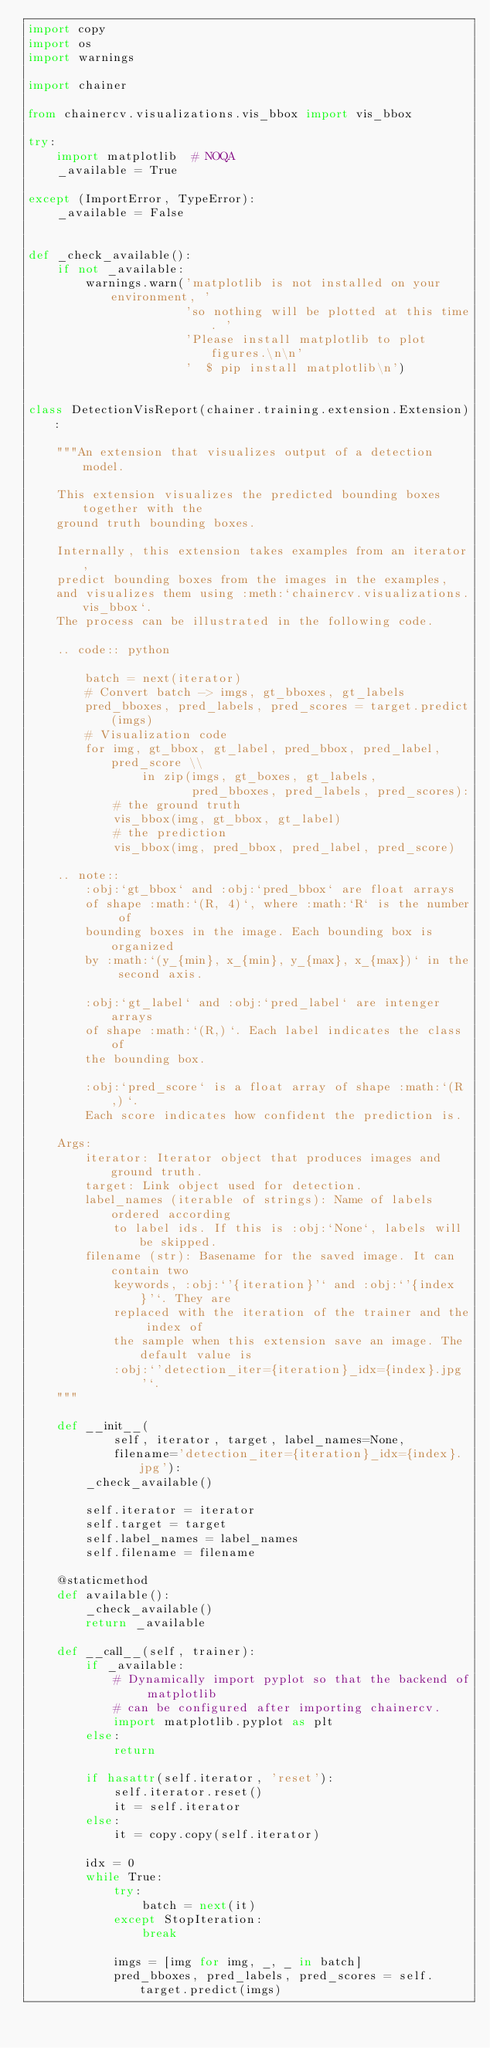<code> <loc_0><loc_0><loc_500><loc_500><_Python_>import copy
import os
import warnings

import chainer

from chainercv.visualizations.vis_bbox import vis_bbox

try:
    import matplotlib  # NOQA
    _available = True

except (ImportError, TypeError):
    _available = False


def _check_available():
    if not _available:
        warnings.warn('matplotlib is not installed on your environment, '
                      'so nothing will be plotted at this time. '
                      'Please install matplotlib to plot figures.\n\n'
                      '  $ pip install matplotlib\n')


class DetectionVisReport(chainer.training.extension.Extension):

    """An extension that visualizes output of a detection model.

    This extension visualizes the predicted bounding boxes together with the
    ground truth bounding boxes.

    Internally, this extension takes examples from an iterator,
    predict bounding boxes from the images in the examples,
    and visualizes them using :meth:`chainercv.visualizations.vis_bbox`.
    The process can be illustrated in the following code.

    .. code:: python

        batch = next(iterator)
        # Convert batch -> imgs, gt_bboxes, gt_labels
        pred_bboxes, pred_labels, pred_scores = target.predict(imgs)
        # Visualization code
        for img, gt_bbox, gt_label, pred_bbox, pred_label, pred_score \\
                in zip(imgs, gt_boxes, gt_labels,
                       pred_bboxes, pred_labels, pred_scores):
            # the ground truth
            vis_bbox(img, gt_bbox, gt_label)
            # the prediction
            vis_bbox(img, pred_bbox, pred_label, pred_score)

    .. note::
        :obj:`gt_bbox` and :obj:`pred_bbox` are float arrays
        of shape :math:`(R, 4)`, where :math:`R` is the number of
        bounding boxes in the image. Each bounding box is organized
        by :math:`(y_{min}, x_{min}, y_{max}, x_{max})` in the second axis.

        :obj:`gt_label` and :obj:`pred_label` are intenger arrays
        of shape :math:`(R,)`. Each label indicates the class of
        the bounding box.

        :obj:`pred_score` is a float array of shape :math:`(R,)`.
        Each score indicates how confident the prediction is.

    Args:
        iterator: Iterator object that produces images and ground truth.
        target: Link object used for detection.
        label_names (iterable of strings): Name of labels ordered according
            to label ids. If this is :obj:`None`, labels will be skipped.
        filename (str): Basename for the saved image. It can contain two
            keywords, :obj:`'{iteration}'` and :obj:`'{index}'`. They are
            replaced with the iteration of the trainer and the index of
            the sample when this extension save an image. The default value is
            :obj:`'detection_iter={iteration}_idx={index}.jpg'`.
    """

    def __init__(
            self, iterator, target, label_names=None,
            filename='detection_iter={iteration}_idx={index}.jpg'):
        _check_available()

        self.iterator = iterator
        self.target = target
        self.label_names = label_names
        self.filename = filename

    @staticmethod
    def available():
        _check_available()
        return _available

    def __call__(self, trainer):
        if _available:
            # Dynamically import pyplot so that the backend of matplotlib
            # can be configured after importing chainercv.
            import matplotlib.pyplot as plt
        else:
            return

        if hasattr(self.iterator, 'reset'):
            self.iterator.reset()
            it = self.iterator
        else:
            it = copy.copy(self.iterator)

        idx = 0
        while True:
            try:
                batch = next(it)
            except StopIteration:
                break

            imgs = [img for img, _, _ in batch]
            pred_bboxes, pred_labels, pred_scores = self.target.predict(imgs)
</code> 